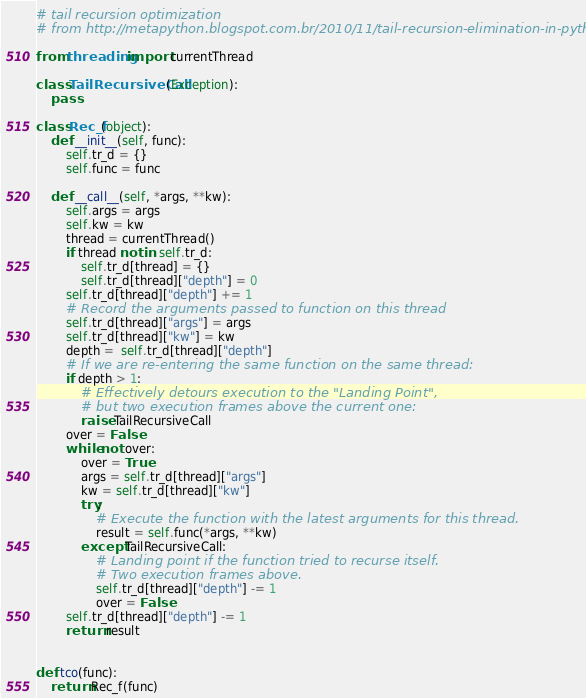<code> <loc_0><loc_0><loc_500><loc_500><_Python_># tail recursion optimization
# from http://metapython.blogspot.com.br/2010/11/tail-recursion-elimination-in-python.html

from threading import currentThread

class TailRecursiveCall(Exception):
    pass

class Rec_f(object):
    def __init__(self, func):
        self.tr_d = {}
        self.func = func

    def __call__(self, *args, **kw):
        self.args = args
        self.kw = kw
        thread = currentThread()
        if thread not in self.tr_d:
            self.tr_d[thread] = {}
            self.tr_d[thread]["depth"] = 0
        self.tr_d[thread]["depth"] += 1
        # Record the arguments passed to function on this thread
        self.tr_d[thread]["args"] = args
        self.tr_d[thread]["kw"] = kw
        depth =  self.tr_d[thread]["depth"]
        # If we are re-entering the same function on the same thread:
        if depth > 1:
            # Effectively detours execution to the "Landing Point",
            # but two execution frames above the current one:
            raise TailRecursiveCall
        over = False
        while not over:
            over = True
            args = self.tr_d[thread]["args"]
            kw = self.tr_d[thread]["kw"]
            try:
                # Execute the function with the latest arguments for this thread.
                result = self.func(*args, **kw)
            except TailRecursiveCall:
                # Landing point if the function tried to recurse itself.
                # Two execution frames above.
                self.tr_d[thread]["depth"] -= 1
                over = False
        self.tr_d[thread]["depth"] -= 1
        return result


def tco(func):
    return Rec_f(func)</code> 